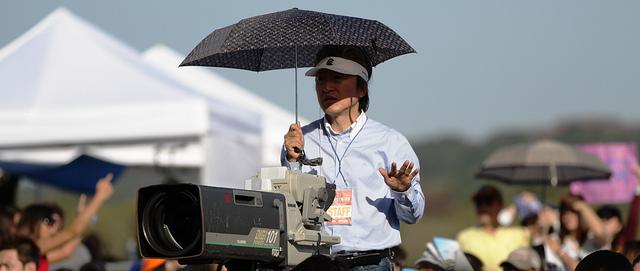There are 4 sun protectors what colors are they?
Concise answer only. White. Why is the person holding an umbrella?
Write a very short answer. To block sun. Is he wearing a hard hat?
Concise answer only. No. Is this person's face painted?
Short answer required. No. 